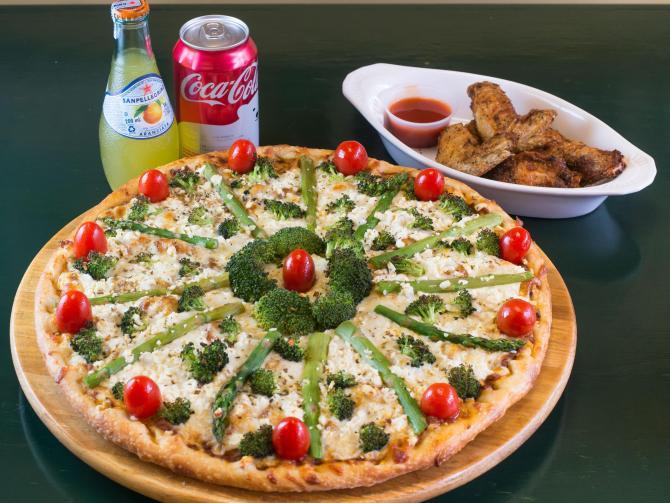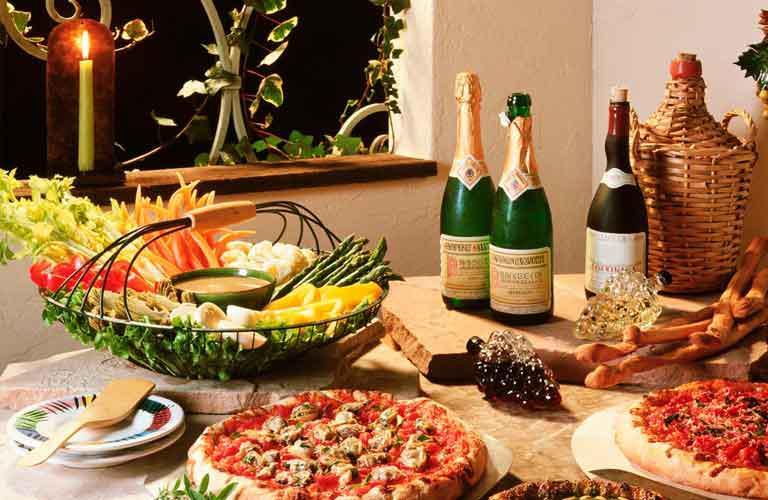The first image is the image on the left, the second image is the image on the right. Assess this claim about the two images: "An unopened container of soda is served with a pizza in one of the images.". Correct or not? Answer yes or no. Yes. The first image is the image on the left, the second image is the image on the right. Given the left and right images, does the statement "One image includes salads on plates, a green bell pepper and a small white bowl of orange shredded cheese near two pizzas." hold true? Answer yes or no. No. 